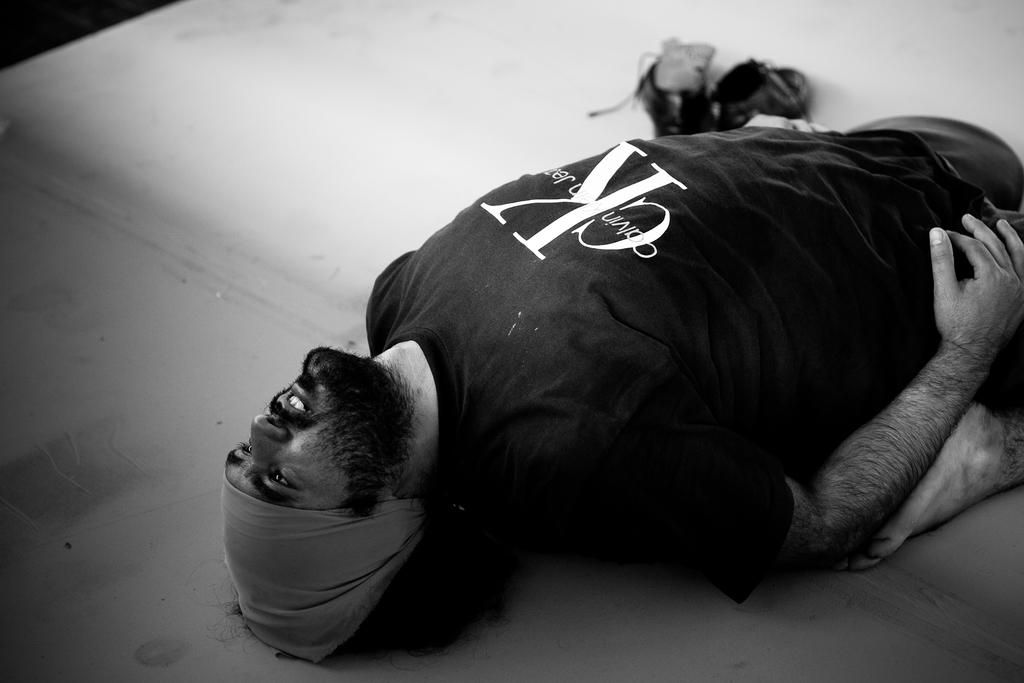What is the position of the person in the image? There is a person lying on the floor in the image. What else can be seen in the image besides the person? Footwear is visible at the top of the image. What arithmetic problem is the person trying to solve in the image? There is no indication of an arithmetic problem in the image; the person is simply lying on the floor. 